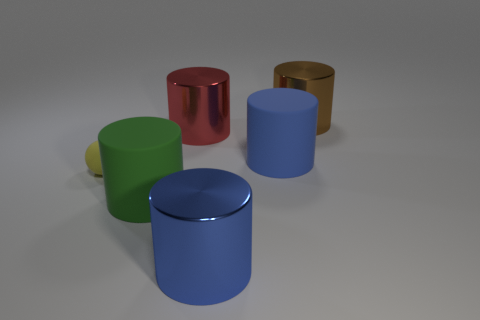Are there any other things that have the same size as the sphere?
Make the answer very short. No. Is there any other thing that has the same shape as the small yellow matte object?
Make the answer very short. No. What number of other objects are the same color as the tiny matte thing?
Provide a succinct answer. 0. Is the size of the metallic cylinder left of the blue metal object the same as the blue rubber cylinder that is right of the yellow object?
Your response must be concise. Yes. Are there an equal number of big red objects that are in front of the tiny sphere and objects that are on the left side of the big blue metallic cylinder?
Make the answer very short. No. Are there any other things that have the same material as the ball?
Your answer should be very brief. Yes. There is a brown metallic cylinder; does it have the same size as the blue cylinder that is in front of the yellow sphere?
Keep it short and to the point. Yes. There is a big cylinder in front of the rubber cylinder that is in front of the small rubber object; what is its material?
Your answer should be very brief. Metal. Are there an equal number of tiny yellow matte things that are in front of the large blue metal thing and large cyan metal cubes?
Offer a very short reply. Yes. There is a cylinder that is to the right of the green matte cylinder and in front of the small yellow rubber ball; what size is it?
Give a very brief answer. Large. 